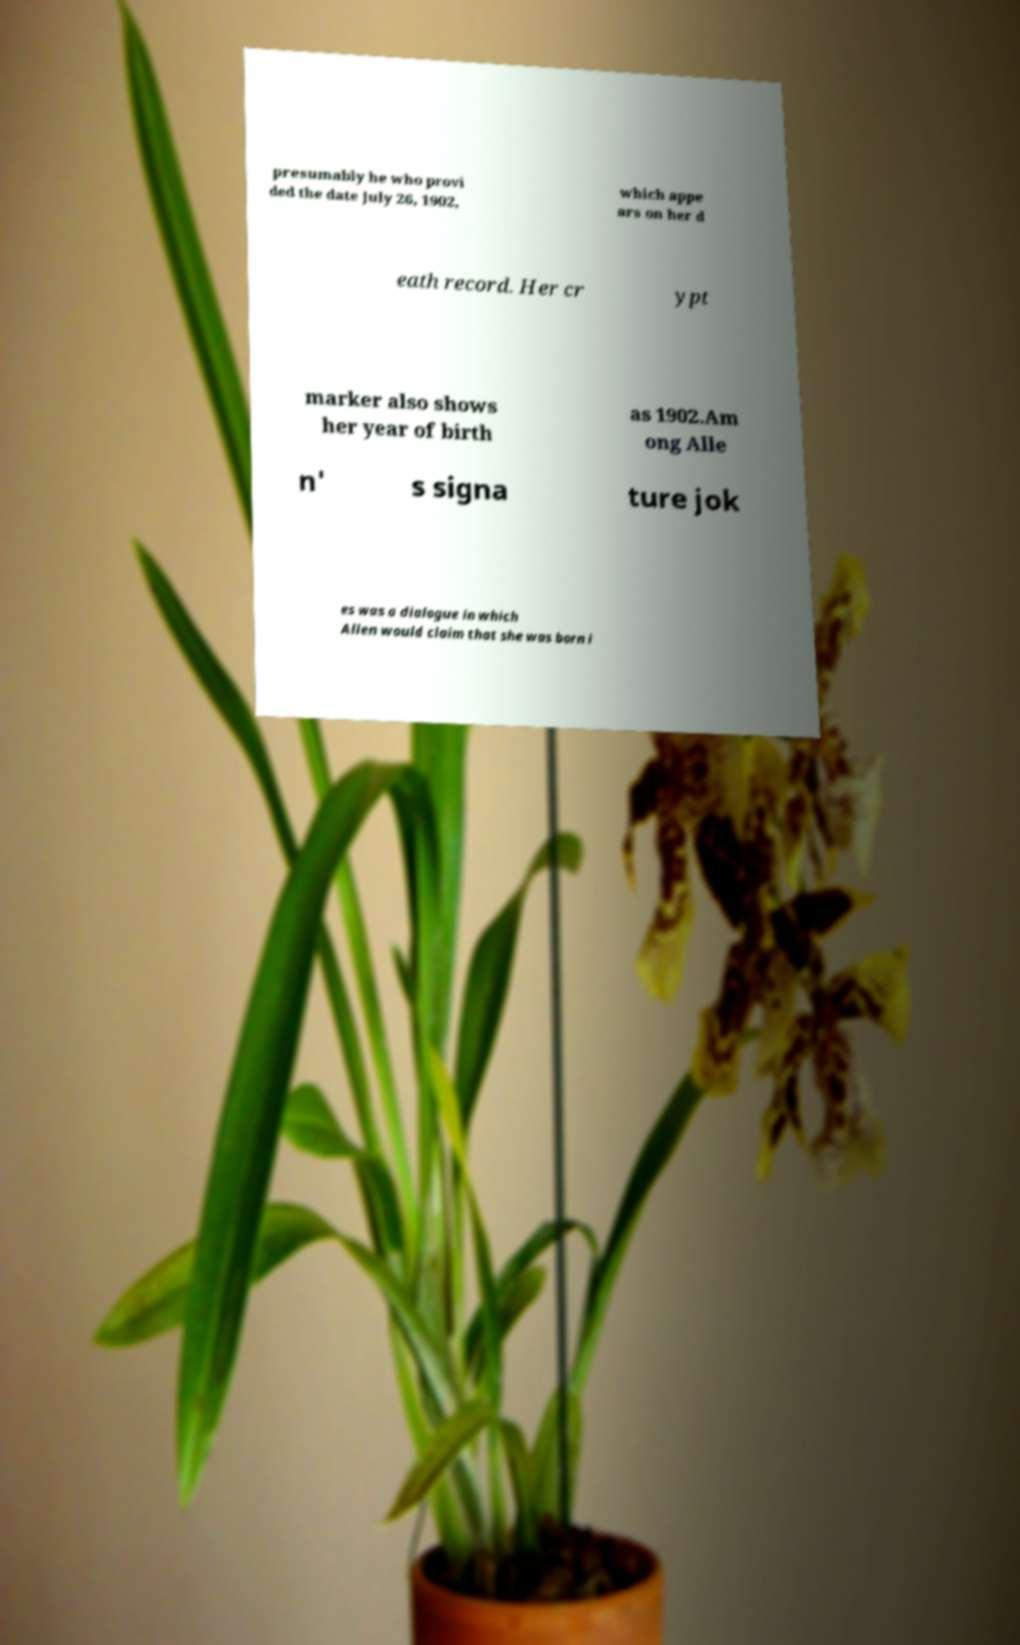Could you extract and type out the text from this image? presumably he who provi ded the date July 26, 1902, which appe ars on her d eath record. Her cr ypt marker also shows her year of birth as 1902.Am ong Alle n' s signa ture jok es was a dialogue in which Allen would claim that she was born i 